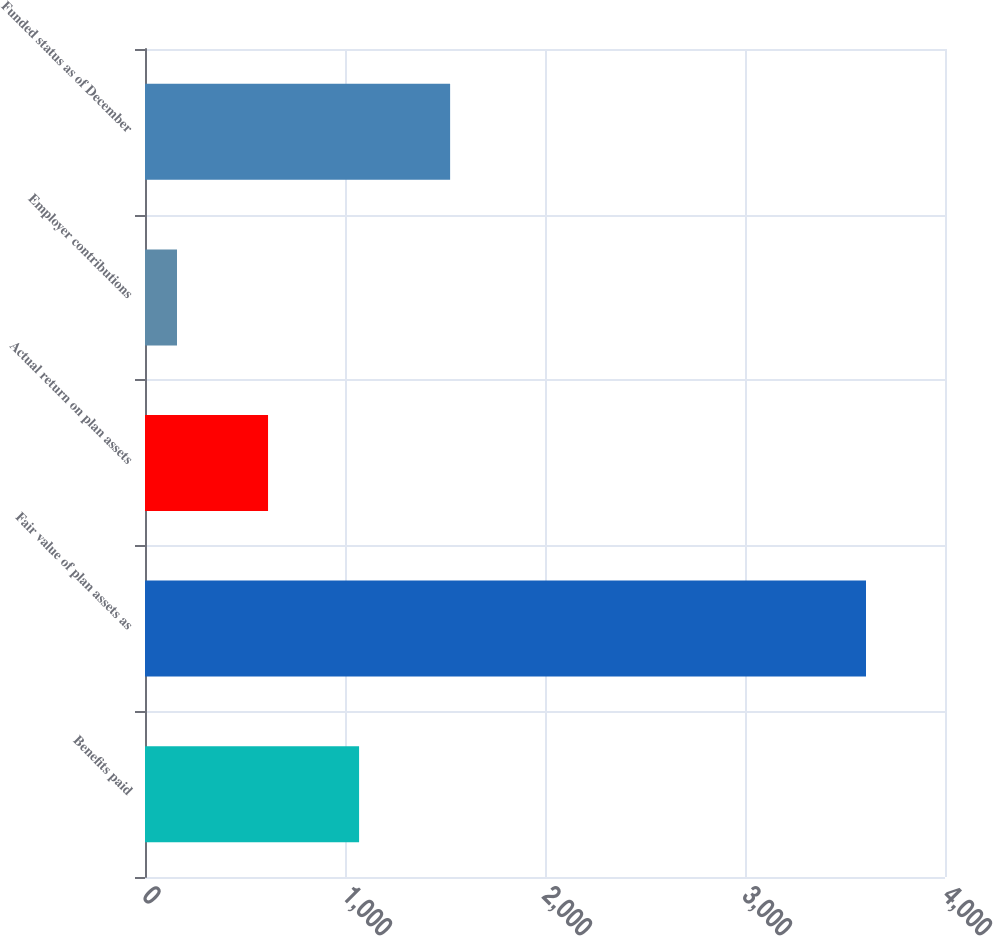Convert chart. <chart><loc_0><loc_0><loc_500><loc_500><bar_chart><fcel>Benefits paid<fcel>Fair value of plan assets as<fcel>Actual return on plan assets<fcel>Employer contributions<fcel>Funded status as of December<nl><fcel>1070.4<fcel>3605<fcel>615.2<fcel>160<fcel>1525.6<nl></chart> 